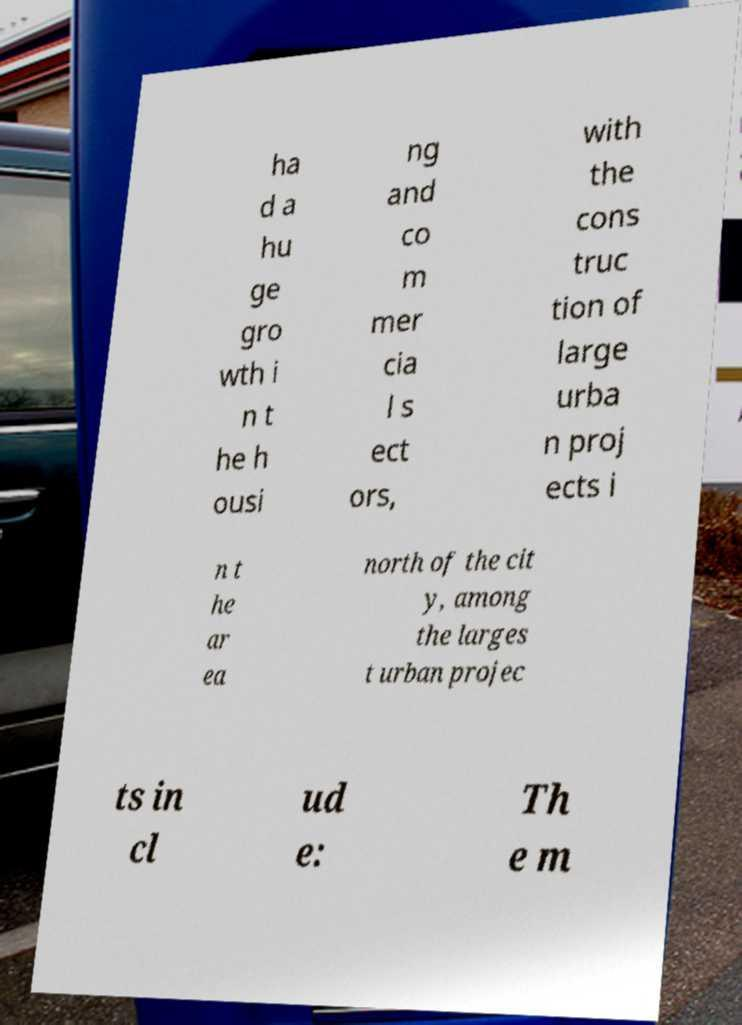Please read and relay the text visible in this image. What does it say? ha d a hu ge gro wth i n t he h ousi ng and co m mer cia l s ect ors, with the cons truc tion of large urba n proj ects i n t he ar ea north of the cit y, among the larges t urban projec ts in cl ud e: Th e m 